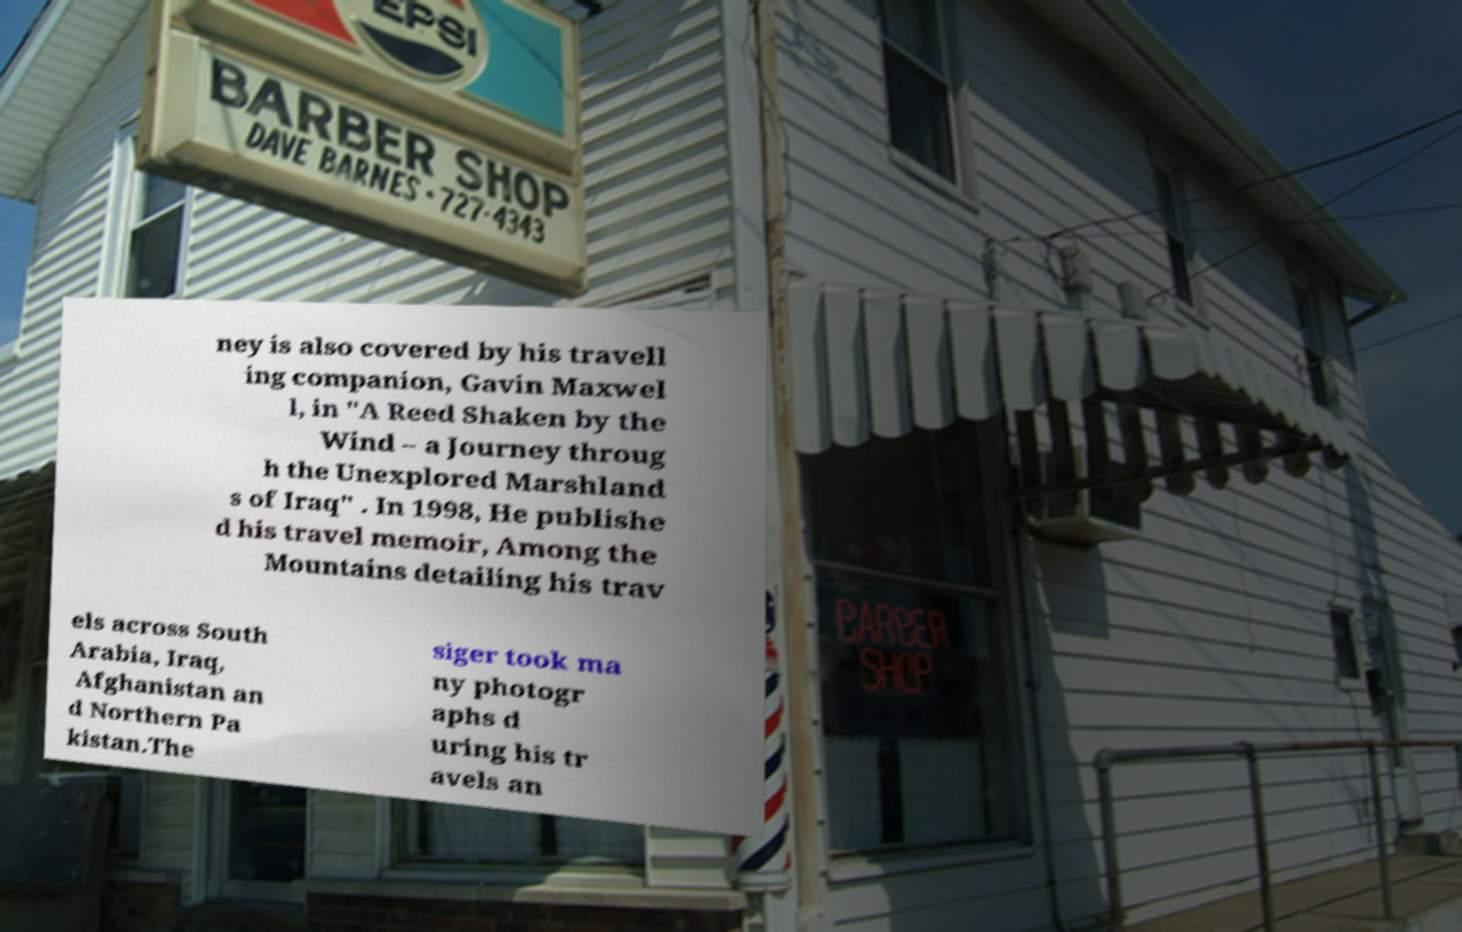What messages or text are displayed in this image? I need them in a readable, typed format. ney is also covered by his travell ing companion, Gavin Maxwel l, in "A Reed Shaken by the Wind – a Journey throug h the Unexplored Marshland s of Iraq" . In 1998, He publishe d his travel memoir, Among the Mountains detailing his trav els across South Arabia, Iraq, Afghanistan an d Northern Pa kistan.The siger took ma ny photogr aphs d uring his tr avels an 